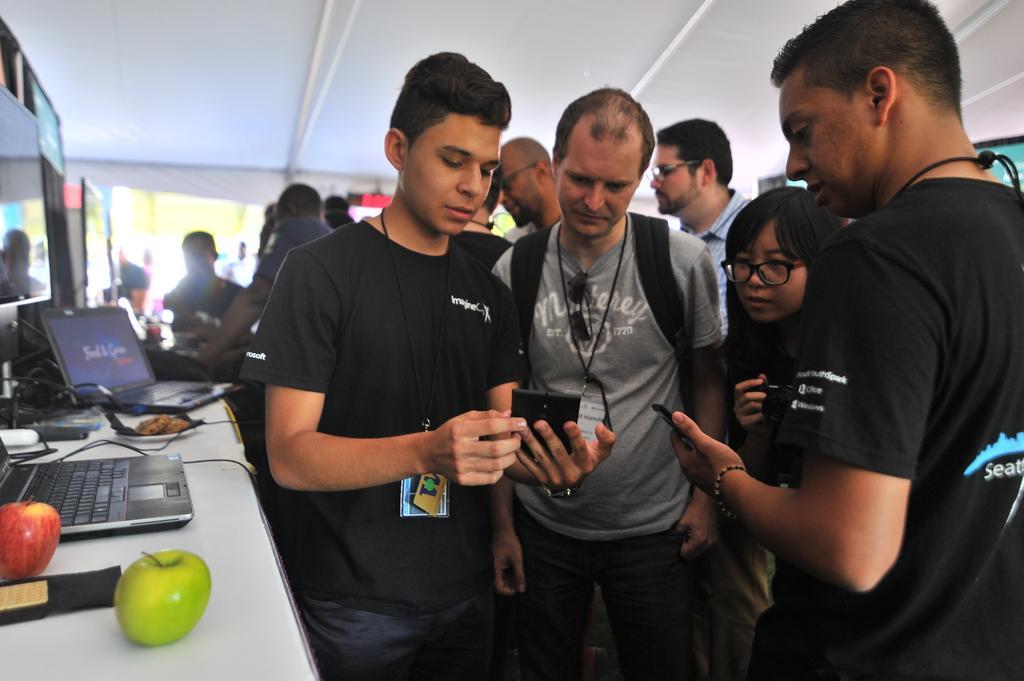Could you give a brief overview of what you see in this image? There are few people standing and watching. Two people are holding mobile phones in their hands. This is the table with two laptops, one red apple, one green apple, a plate, cables and few other objects on it. In the background, I can see few people standing. These are the screens. 